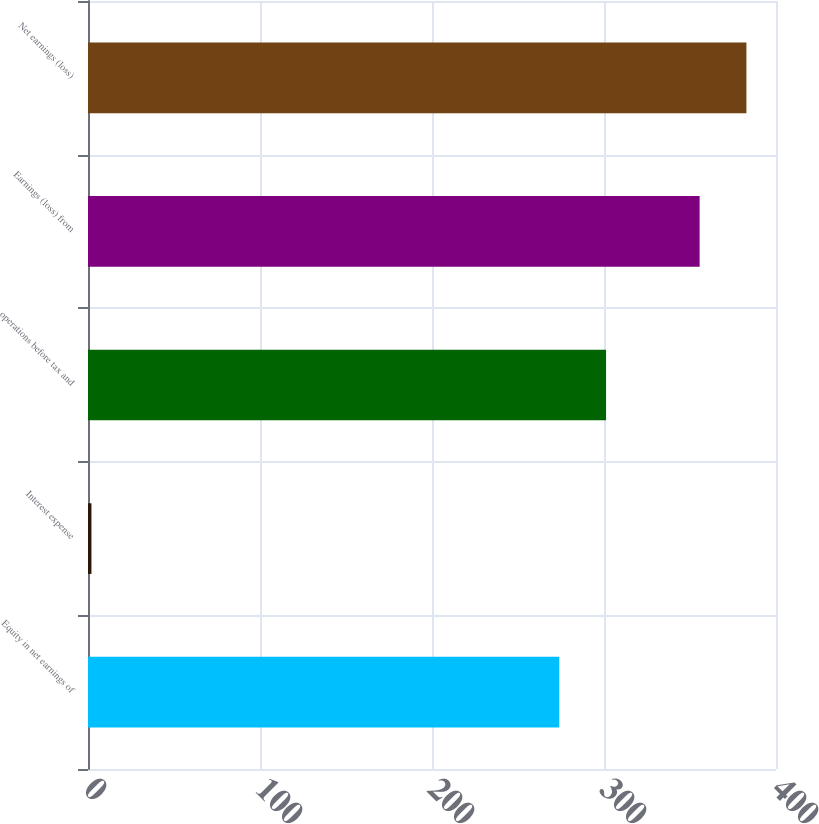Convert chart. <chart><loc_0><loc_0><loc_500><loc_500><bar_chart><fcel>Equity in net earnings of<fcel>Interest expense<fcel>operations before tax and<fcel>Earnings (loss) from<fcel>Net earnings (loss)<nl><fcel>274<fcel>2<fcel>301.2<fcel>355.6<fcel>382.8<nl></chart> 